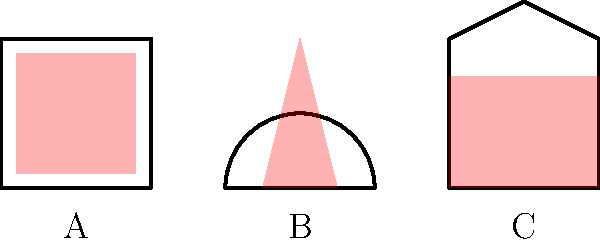As a culinary show producer, you're discussing the impact of cookware on heat distribution with your sibling. Which pot shape shown above would provide the most even heat distribution for cooking delicate sauces that are sensitive to temperature fluctuations? To determine which pot shape provides the most even heat distribution, let's analyze each option:

1. Pot A (Square pot):
   - The heat pattern shows an even distribution throughout the pot.
   - Square corners may create some hot spots, but overall distribution is uniform.

2. Pot B (Round bottom pot):
   - The heat pattern is concentrated at the bottom and narrows towards the top.
   - This creates an uneven temperature gradient, with the bottom being much hotter than the upper portions.

3. Pot C (Sloped sides pot):
   - The heat pattern is wide at the bottom and narrows towards the top.
   - This creates a moderate temperature gradient, but not as extreme as Pot B.

For cooking delicate sauces sensitive to temperature fluctuations, we want the most even heat distribution possible. This helps prevent scorching or uneven cooking.

Pot A provides the most even heat distribution among the three options. The square shape allows for consistent heat across the bottom and sides of the pot, which is ideal for maintaining a steady temperature throughout the sauce.

While Pot A may have slight hot spots in the corners, it still offers a more uniform heat distribution compared to the other options. This evenness is crucial for delicate sauces that require precise temperature control.
Answer: Pot A (Square pot) 